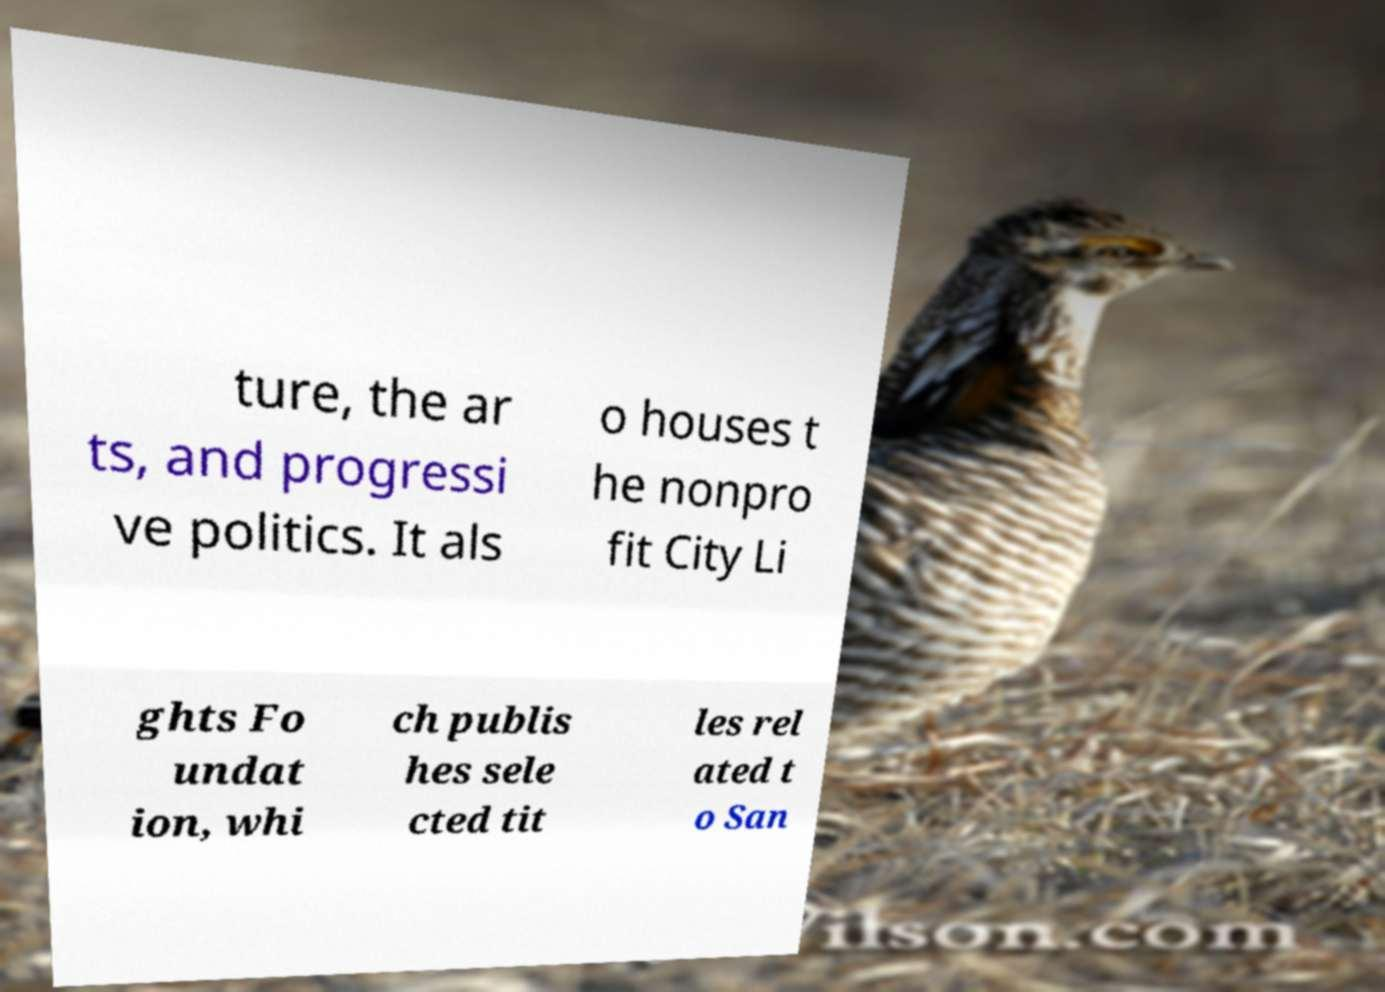Please read and relay the text visible in this image. What does it say? ture, the ar ts, and progressi ve politics. It als o houses t he nonpro fit City Li ghts Fo undat ion, whi ch publis hes sele cted tit les rel ated t o San 